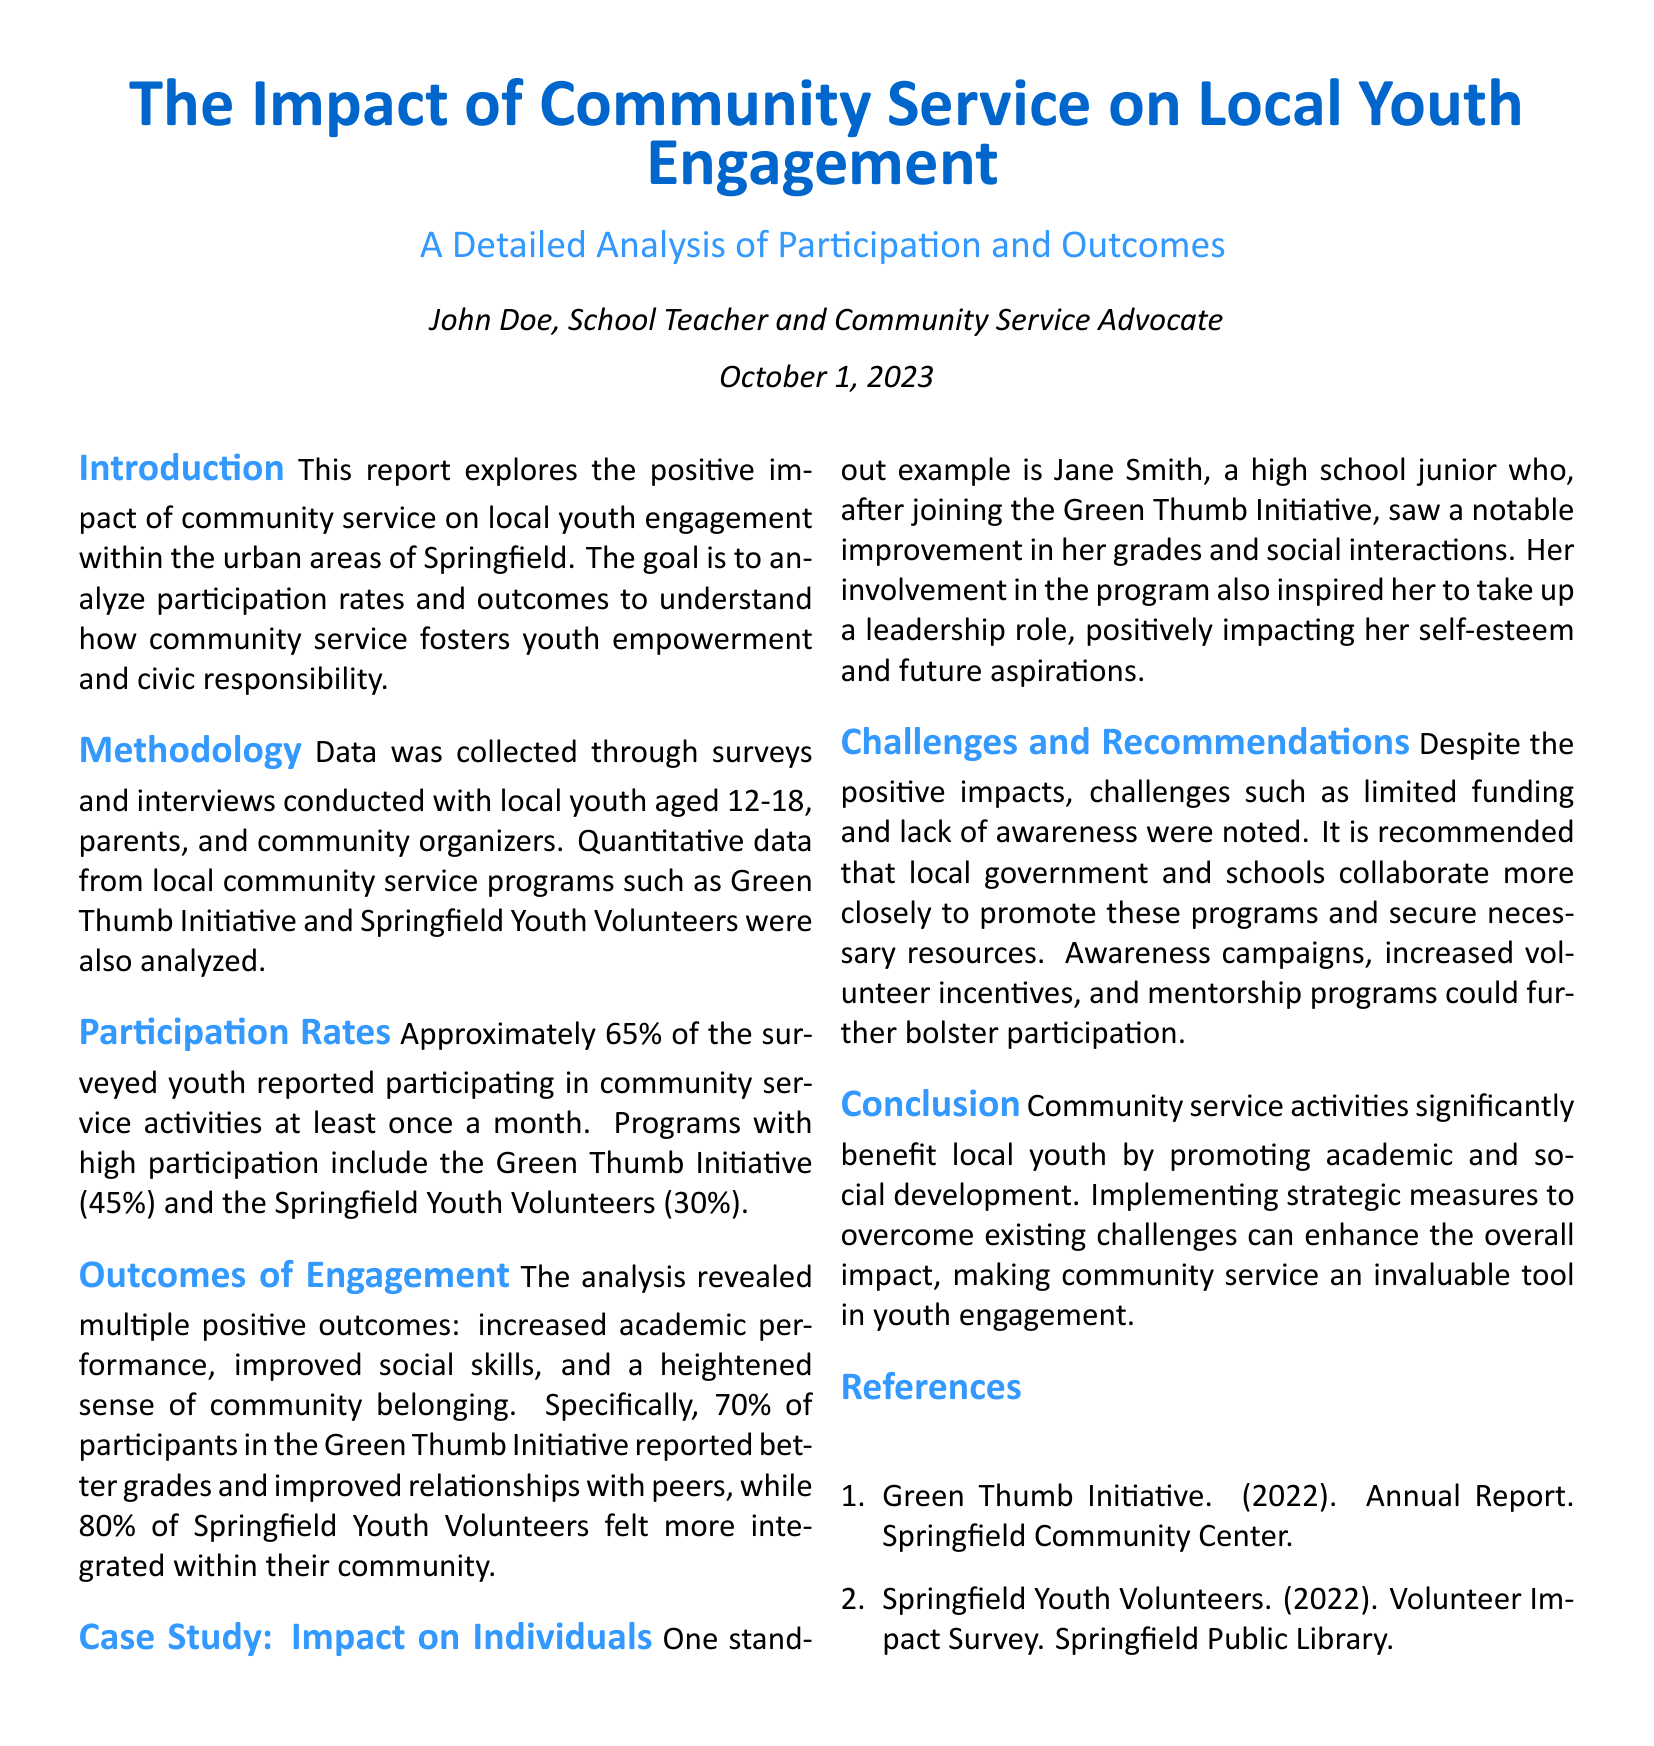what is the title of the report? The title of the report is found in the header section of the document.
Answer: The Impact of Community Service on Local Youth Engagement who authored the report? The author information is provided under the title in the document.
Answer: John Doe what percentage of surveyed youth reported participating in community service activities? The participation rate is directly mentioned in the document's participation rates section.
Answer: Approximately 65% which program had the highest participation rate? The document specifies the participation rates of different programs.
Answer: Green Thumb Initiative what positive outcome did 70% of participants in the Green Thumb Initiative report? This outcome is stated in the outcomes of engagement section of the document.
Answer: Better grades what is one recommended action to overcome challenges faced by community service programs? Recommendations to address challenges are outlined in the challenges and recommendations section of the report.
Answer: Awareness campaigns which age group was surveyed in this study? The age group surveyed is mentioned in the methodology section.
Answer: 12-18 what are the two programs analyzed in the report? The programs are listed in the methodology section of the document.
Answer: Green Thumb Initiative and Springfield Youth Volunteers who is highlighted in the case study? The case study specifically references an individual as an example.
Answer: Jane Smith 